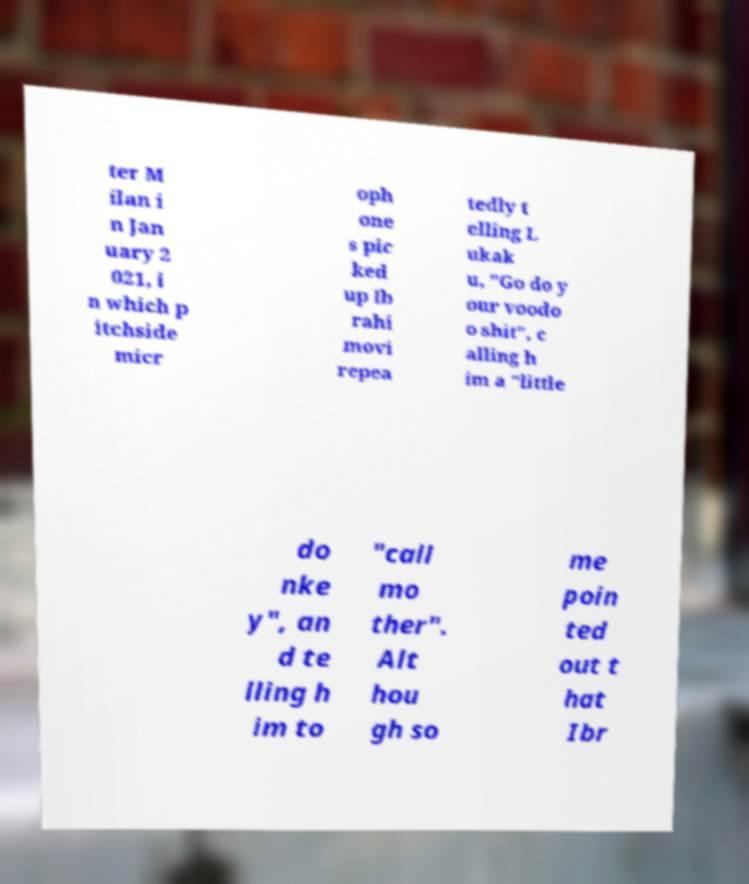What messages or text are displayed in this image? I need them in a readable, typed format. ter M ilan i n Jan uary 2 021, i n which p itchside micr oph one s pic ked up Ib rahi movi repea tedly t elling L ukak u, "Go do y our voodo o shit", c alling h im a "little do nke y", an d te lling h im to "call mo ther". Alt hou gh so me poin ted out t hat Ibr 